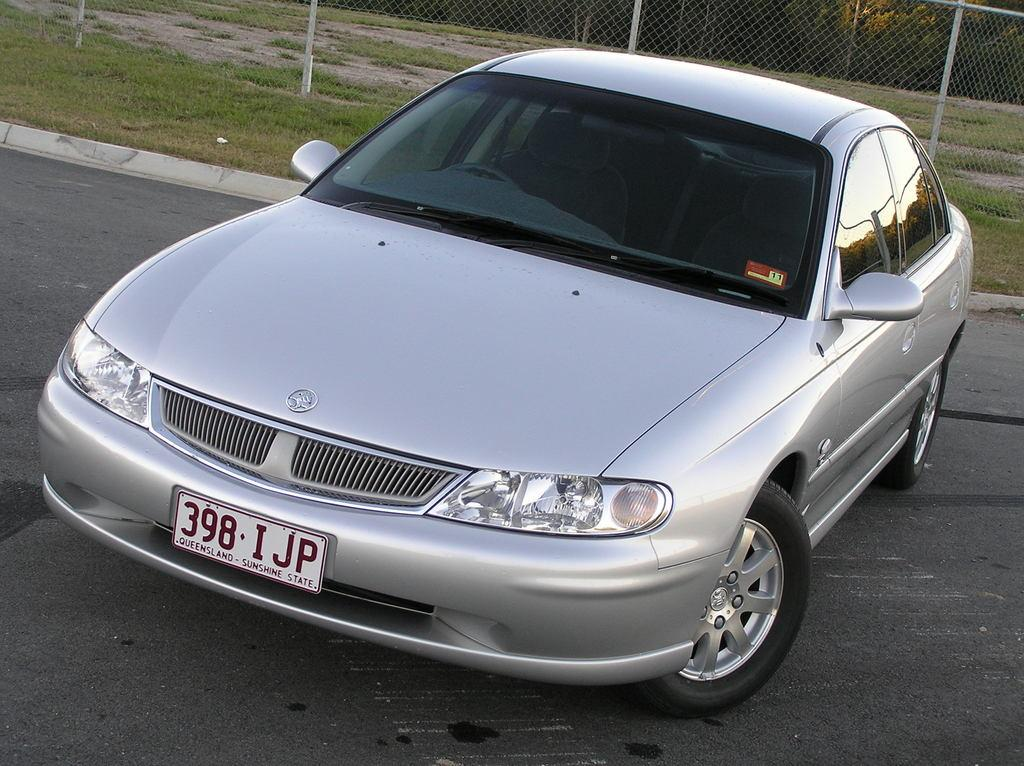What is the main subject in the center of the image? There is a car in the center of the image. What can be seen in the background of the image? There is grass and a fence in the background of the image. Where is the grass located in relation to the car? The grass is in the background of the image, behind the car. What is the texture of the grass in the image? The texture of the grass cannot be determined from the image alone. How many servants are visible in the image? There are no servants present in the image. What type of cork is used to secure the fence in the image? There is no cork visible in the image, as it features a car and background elements like grass and a fence. 